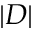<formula> <loc_0><loc_0><loc_500><loc_500>| D |</formula> 